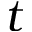Convert formula to latex. <formula><loc_0><loc_0><loc_500><loc_500>t</formula> 